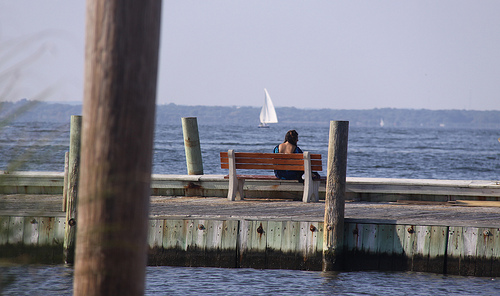<image>
Can you confirm if the sailboat is in front of the bench? Yes. The sailboat is positioned in front of the bench, appearing closer to the camera viewpoint. 